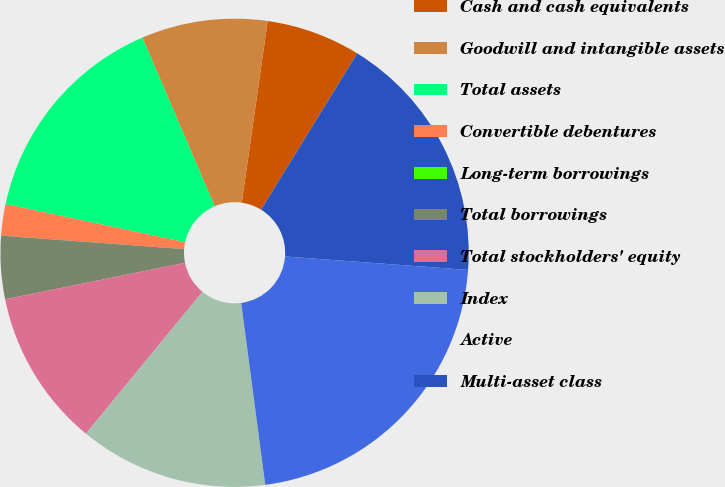<chart> <loc_0><loc_0><loc_500><loc_500><pie_chart><fcel>Cash and cash equivalents<fcel>Goodwill and intangible assets<fcel>Total assets<fcel>Convertible debentures<fcel>Long-term borrowings<fcel>Total borrowings<fcel>Total stockholders' equity<fcel>Index<fcel>Active<fcel>Multi-asset class<nl><fcel>6.52%<fcel>8.7%<fcel>15.22%<fcel>2.17%<fcel>0.0%<fcel>4.35%<fcel>10.87%<fcel>13.04%<fcel>21.74%<fcel>17.39%<nl></chart> 